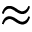Convert formula to latex. <formula><loc_0><loc_0><loc_500><loc_500>\approx</formula> 